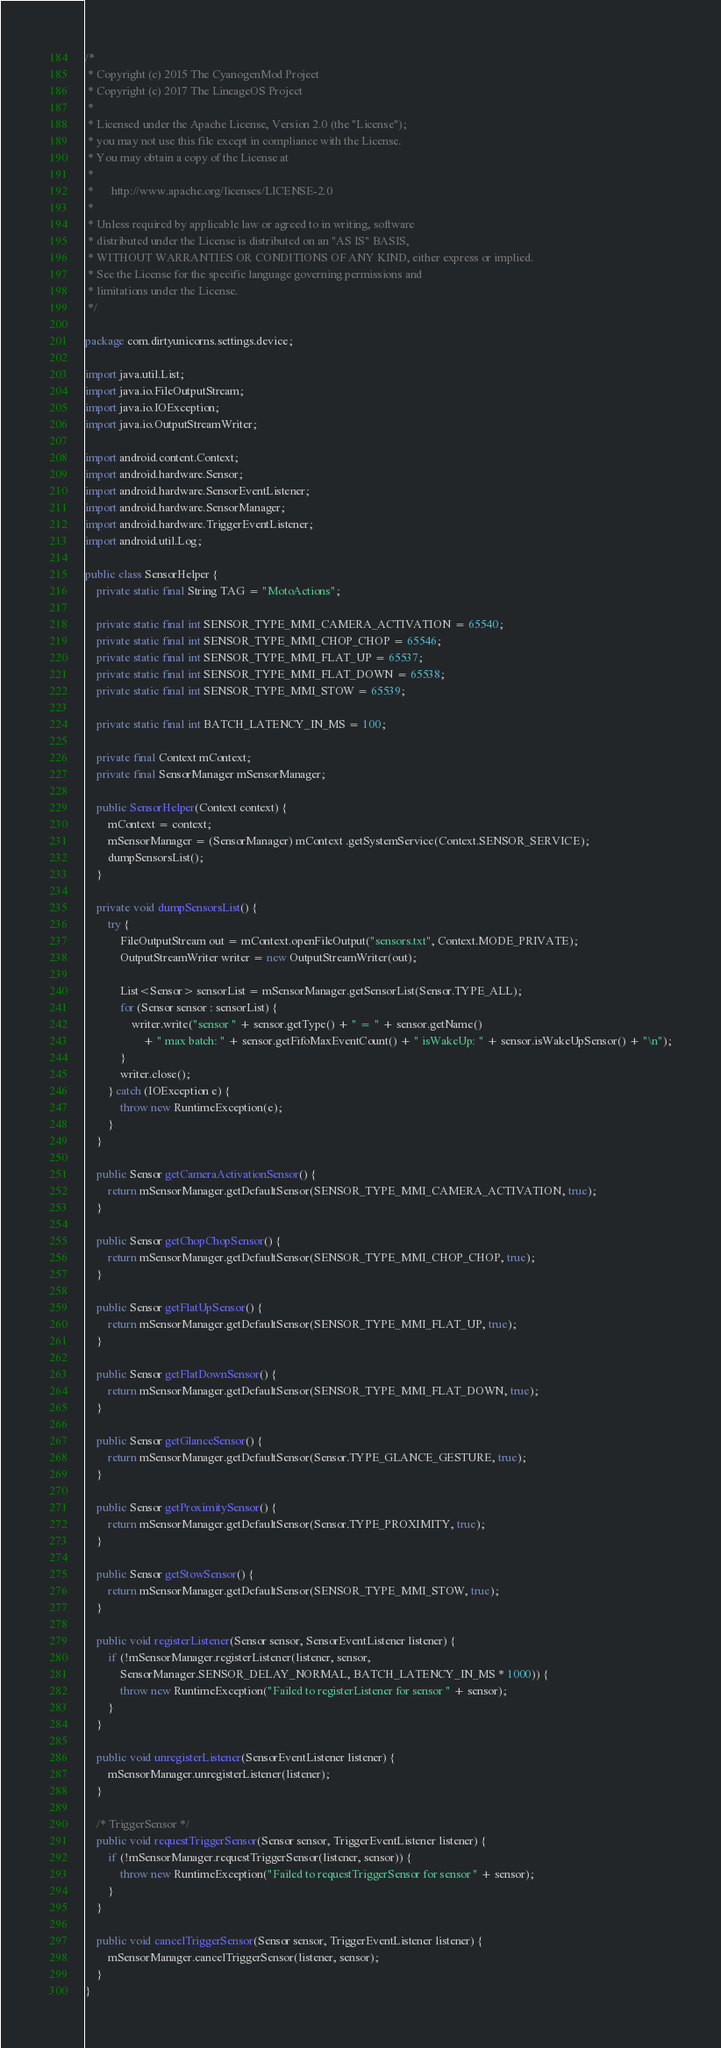<code> <loc_0><loc_0><loc_500><loc_500><_Java_>/*
 * Copyright (c) 2015 The CyanogenMod Project
 * Copyright (c) 2017 The LineageOS Project
 *
 * Licensed under the Apache License, Version 2.0 (the "License");
 * you may not use this file except in compliance with the License.
 * You may obtain a copy of the License at
 *
 *      http://www.apache.org/licenses/LICENSE-2.0
 *
 * Unless required by applicable law or agreed to in writing, software
 * distributed under the License is distributed on an "AS IS" BASIS,
 * WITHOUT WARRANTIES OR CONDITIONS OF ANY KIND, either express or implied.
 * See the License for the specific language governing permissions and
 * limitations under the License.
 */

package com.dirtyunicorns.settings.device;

import java.util.List;
import java.io.FileOutputStream;
import java.io.IOException;
import java.io.OutputStreamWriter;

import android.content.Context;
import android.hardware.Sensor;
import android.hardware.SensorEventListener;
import android.hardware.SensorManager;
import android.hardware.TriggerEventListener;
import android.util.Log;

public class SensorHelper {
    private static final String TAG = "MotoActions";

    private static final int SENSOR_TYPE_MMI_CAMERA_ACTIVATION = 65540;
    private static final int SENSOR_TYPE_MMI_CHOP_CHOP = 65546;
    private static final int SENSOR_TYPE_MMI_FLAT_UP = 65537;
    private static final int SENSOR_TYPE_MMI_FLAT_DOWN = 65538;
    private static final int SENSOR_TYPE_MMI_STOW = 65539;

    private static final int BATCH_LATENCY_IN_MS = 100;

    private final Context mContext;
    private final SensorManager mSensorManager;

    public SensorHelper(Context context) {
        mContext = context;
        mSensorManager = (SensorManager) mContext .getSystemService(Context.SENSOR_SERVICE);
        dumpSensorsList();
    }

    private void dumpSensorsList() {
        try {
            FileOutputStream out = mContext.openFileOutput("sensors.txt", Context.MODE_PRIVATE);
            OutputStreamWriter writer = new OutputStreamWriter(out);

            List<Sensor> sensorList = mSensorManager.getSensorList(Sensor.TYPE_ALL);
            for (Sensor sensor : sensorList) {
                writer.write("sensor " + sensor.getType() + " = " + sensor.getName()
                    + " max batch: " + sensor.getFifoMaxEventCount() + " isWakeUp: " + sensor.isWakeUpSensor() + "\n");
            }
            writer.close();
        } catch (IOException e) {
            throw new RuntimeException(e);
        }
    }

    public Sensor getCameraActivationSensor() {
        return mSensorManager.getDefaultSensor(SENSOR_TYPE_MMI_CAMERA_ACTIVATION, true);
    }

    public Sensor getChopChopSensor() {
        return mSensorManager.getDefaultSensor(SENSOR_TYPE_MMI_CHOP_CHOP, true);
    }

    public Sensor getFlatUpSensor() {
        return mSensorManager.getDefaultSensor(SENSOR_TYPE_MMI_FLAT_UP, true);
    }

    public Sensor getFlatDownSensor() {
        return mSensorManager.getDefaultSensor(SENSOR_TYPE_MMI_FLAT_DOWN, true);
    }

    public Sensor getGlanceSensor() {
        return mSensorManager.getDefaultSensor(Sensor.TYPE_GLANCE_GESTURE, true);
    }

    public Sensor getProximitySensor() {
        return mSensorManager.getDefaultSensor(Sensor.TYPE_PROXIMITY, true);
    }

    public Sensor getStowSensor() {
        return mSensorManager.getDefaultSensor(SENSOR_TYPE_MMI_STOW, true);
    }

    public void registerListener(Sensor sensor, SensorEventListener listener) {
        if (!mSensorManager.registerListener(listener, sensor,
            SensorManager.SENSOR_DELAY_NORMAL, BATCH_LATENCY_IN_MS * 1000)) {
            throw new RuntimeException("Failed to registerListener for sensor " + sensor);
        }
    }

    public void unregisterListener(SensorEventListener listener) {
        mSensorManager.unregisterListener(listener);
    }

    /* TriggerSensor */
    public void requestTriggerSensor(Sensor sensor, TriggerEventListener listener) {
        if (!mSensorManager.requestTriggerSensor(listener, sensor)) {
            throw new RuntimeException("Failed to requestTriggerSensor for sensor " + sensor);
        }
    }

    public void cancelTriggerSensor(Sensor sensor, TriggerEventListener listener) {
        mSensorManager.cancelTriggerSensor(listener, sensor);
    }
}
</code> 